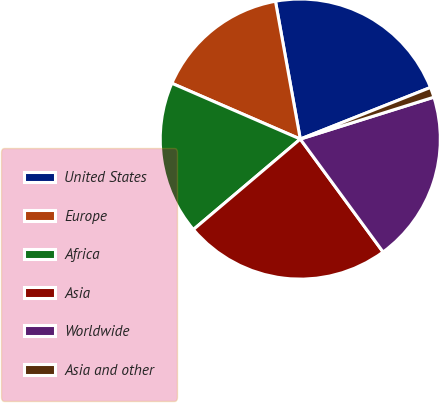Convert chart. <chart><loc_0><loc_0><loc_500><loc_500><pie_chart><fcel>United States<fcel>Europe<fcel>Africa<fcel>Asia<fcel>Worldwide<fcel>Asia and other<nl><fcel>21.83%<fcel>15.64%<fcel>17.7%<fcel>23.89%<fcel>19.77%<fcel>1.17%<nl></chart> 